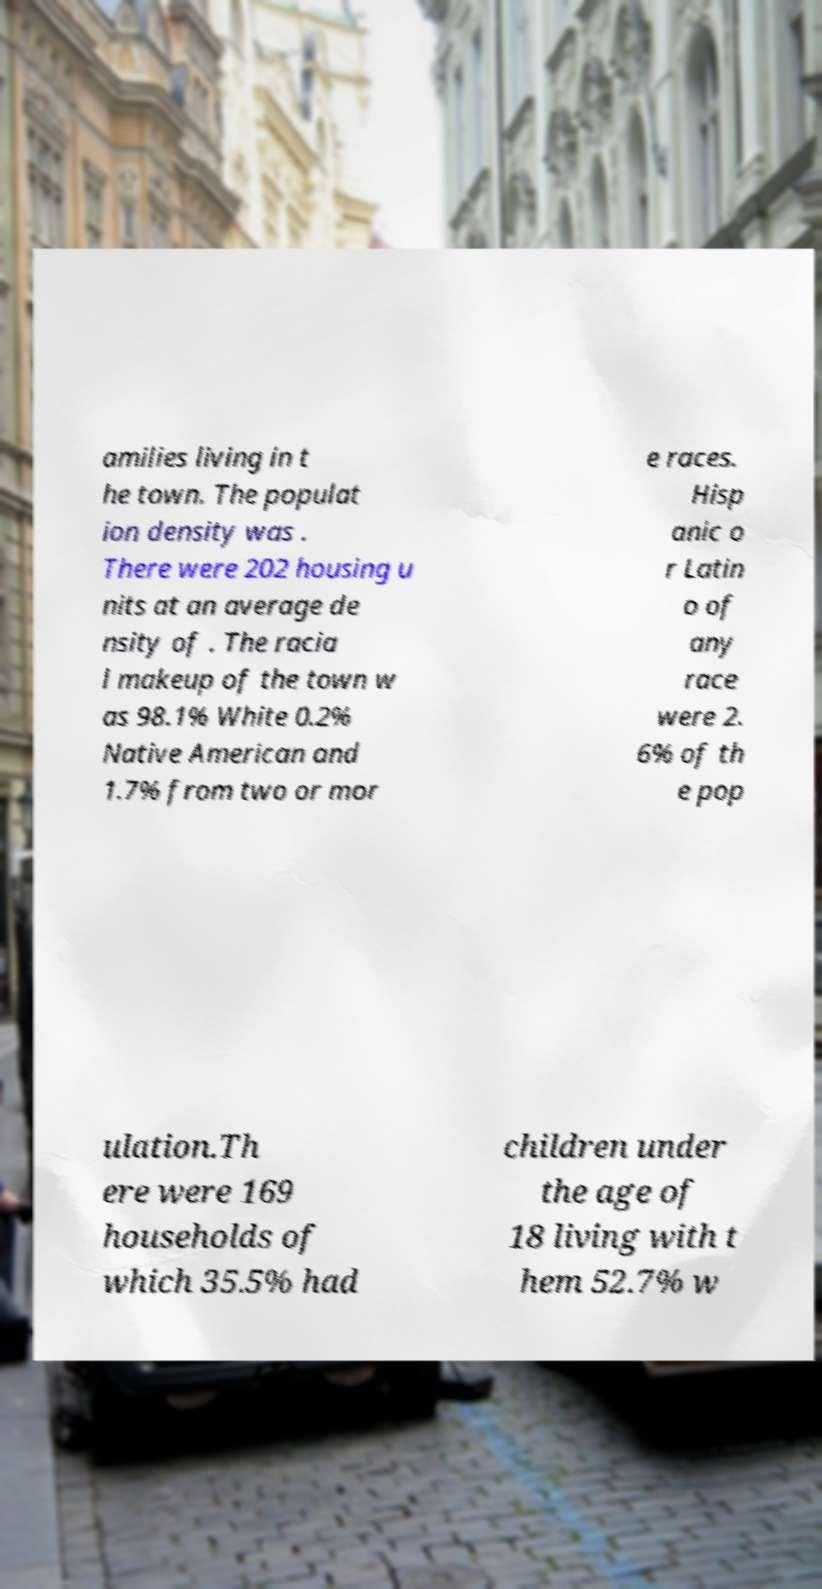Please read and relay the text visible in this image. What does it say? amilies living in t he town. The populat ion density was . There were 202 housing u nits at an average de nsity of . The racia l makeup of the town w as 98.1% White 0.2% Native American and 1.7% from two or mor e races. Hisp anic o r Latin o of any race were 2. 6% of th e pop ulation.Th ere were 169 households of which 35.5% had children under the age of 18 living with t hem 52.7% w 